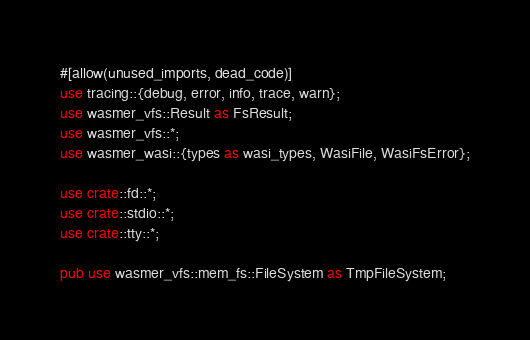<code> <loc_0><loc_0><loc_500><loc_500><_Rust_>#[allow(unused_imports, dead_code)]
use tracing::{debug, error, info, trace, warn};
use wasmer_vfs::Result as FsResult;
use wasmer_vfs::*;
use wasmer_wasi::{types as wasi_types, WasiFile, WasiFsError};

use crate::fd::*;
use crate::stdio::*;
use crate::tty::*;

pub use wasmer_vfs::mem_fs::FileSystem as TmpFileSystem;
</code> 